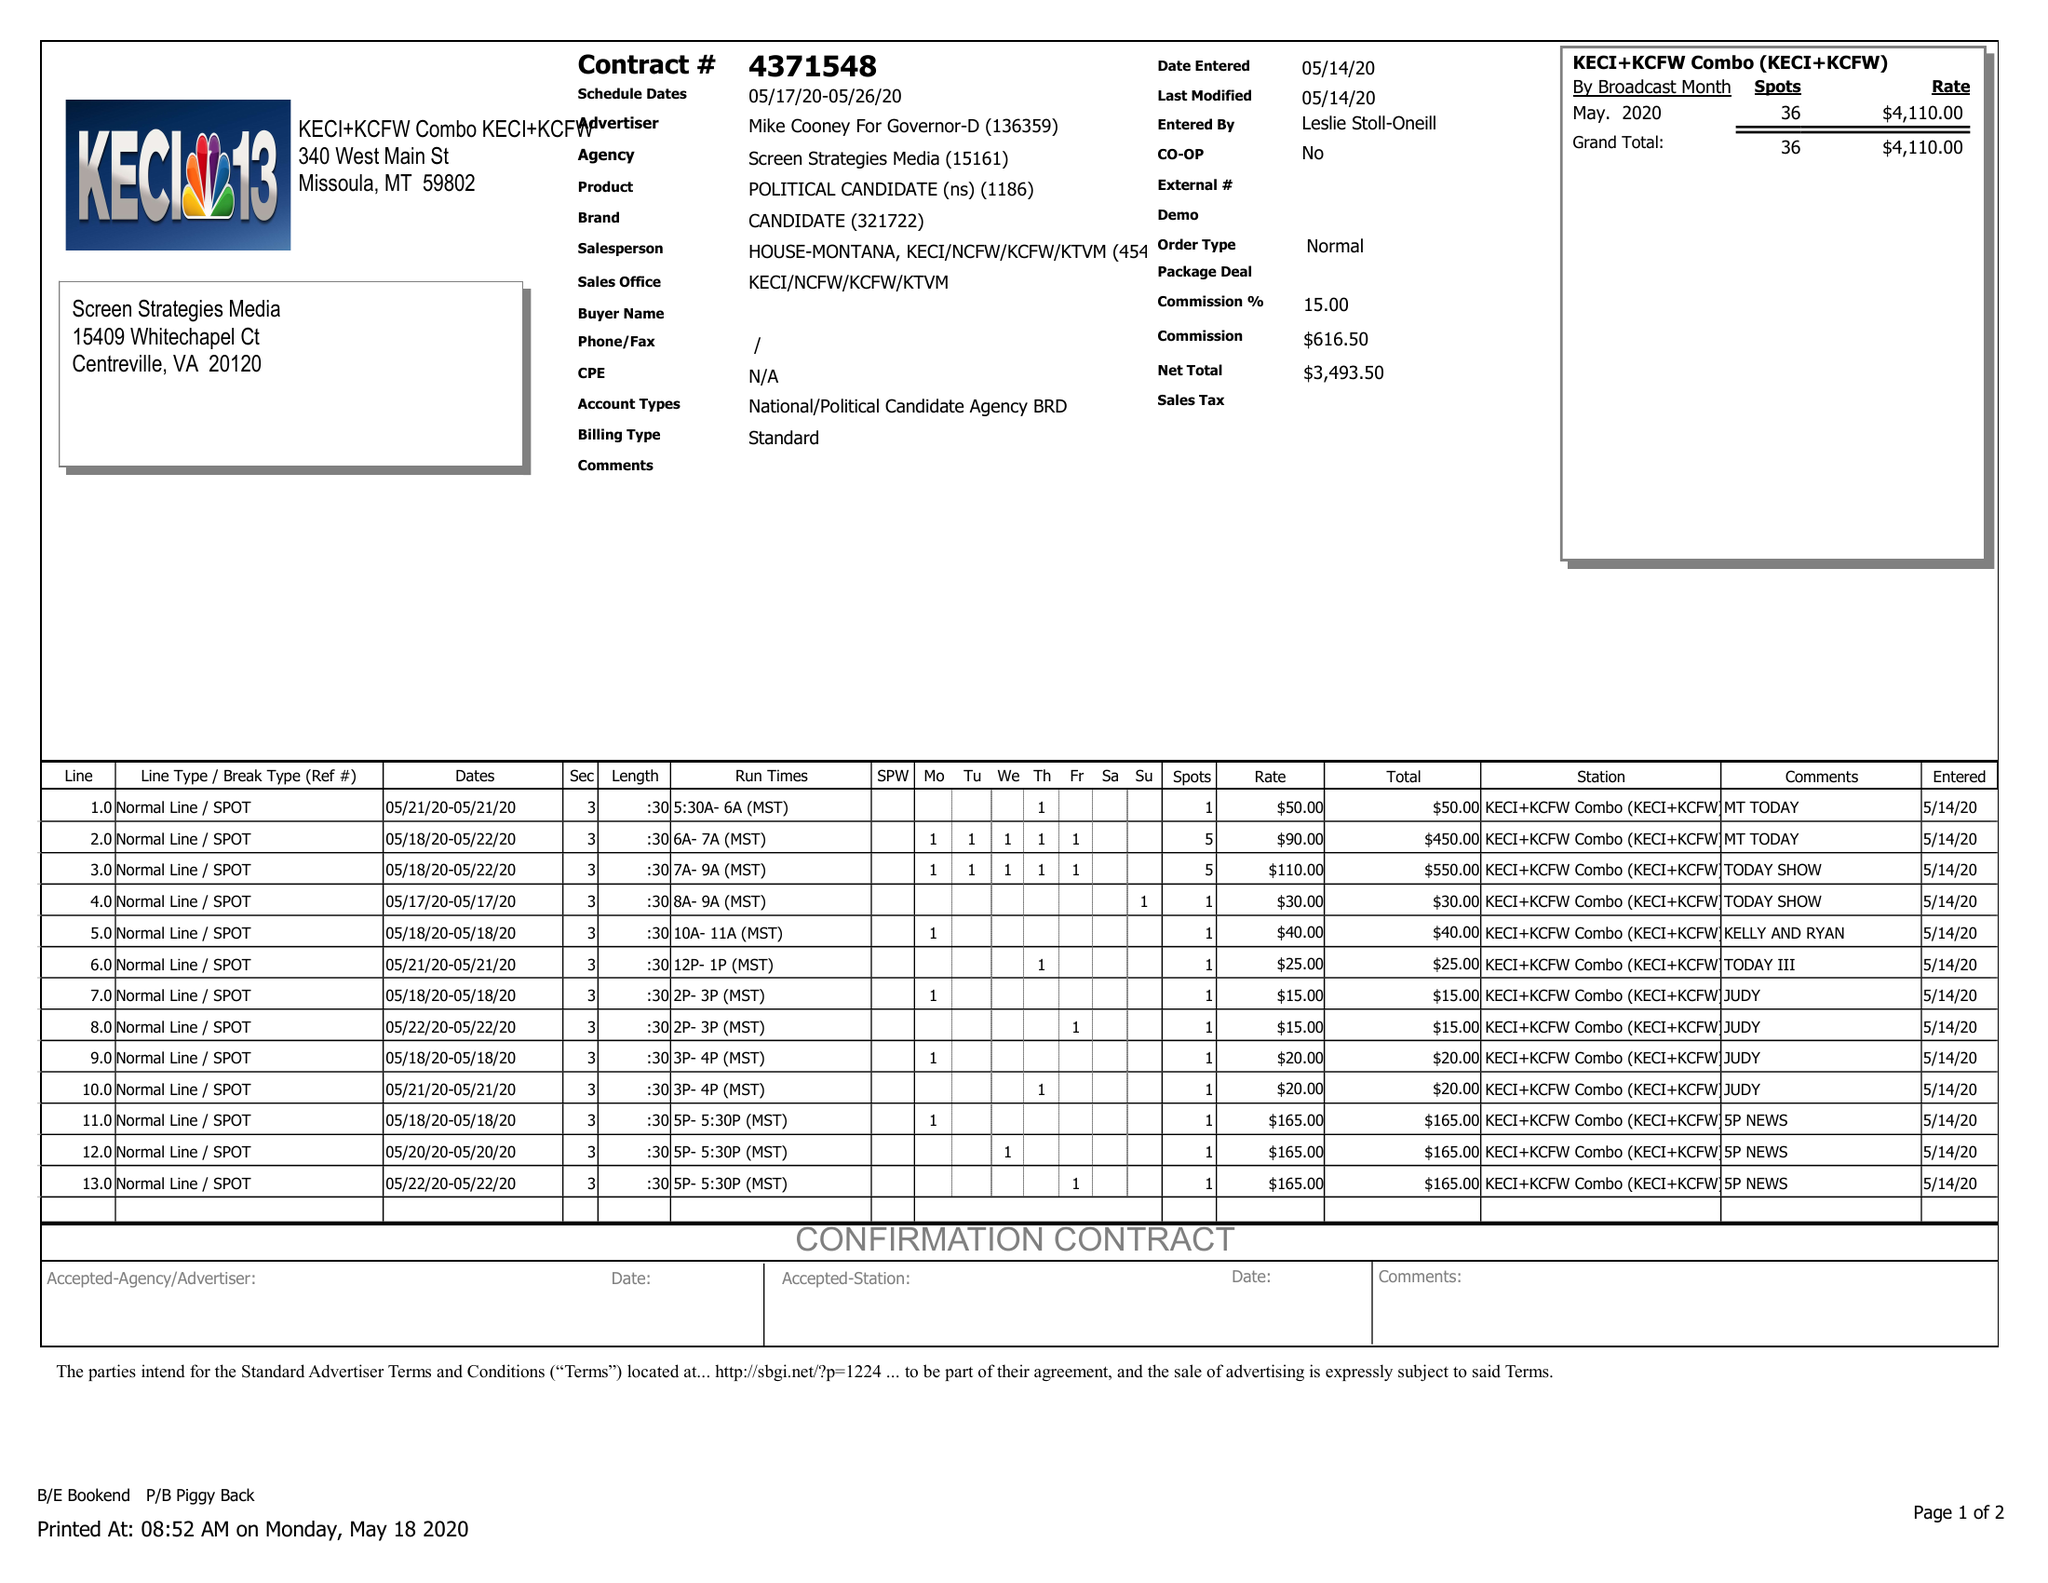What is the value for the flight_from?
Answer the question using a single word or phrase. 05/17/20 